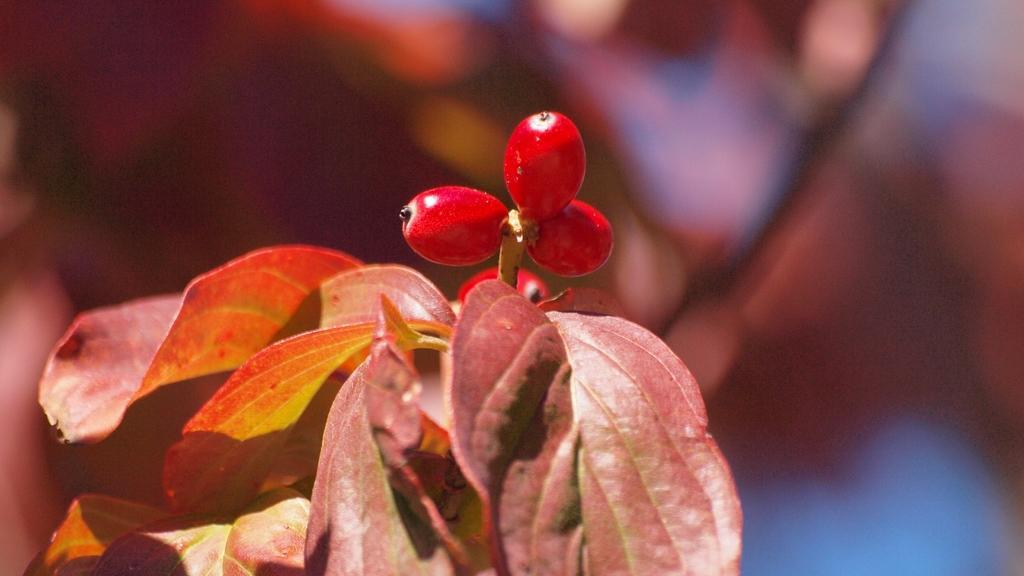Please provide a concise description of this image. In the picture we can see a plant which is some reddish in color and some small fruits to it which are also red in color. 